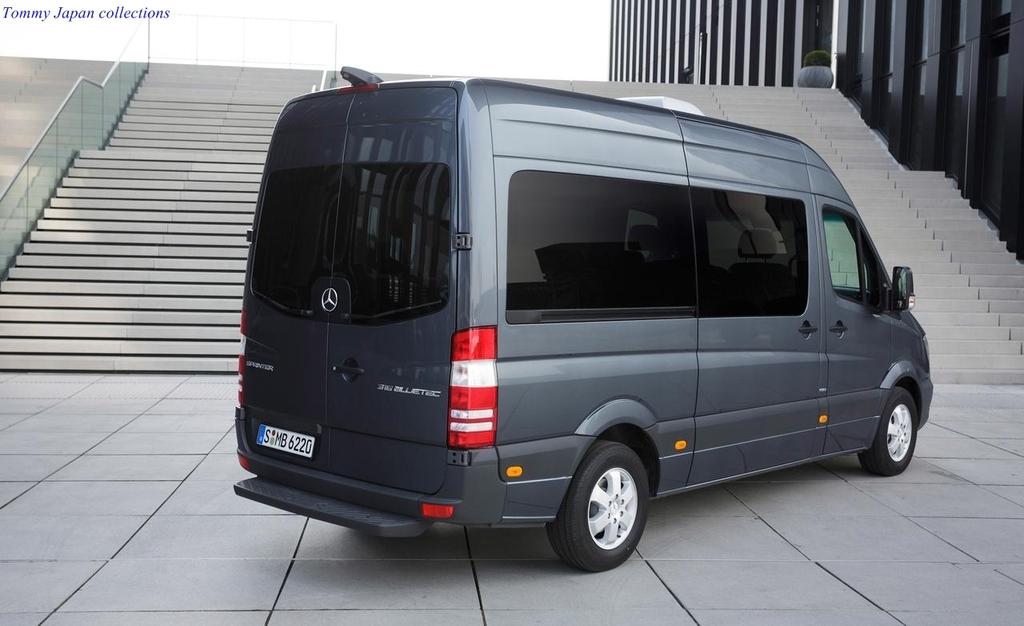What is the license plate of the van?
Offer a very short reply. Smb6220. What brand is the car?
Provide a short and direct response. Mercedes. 